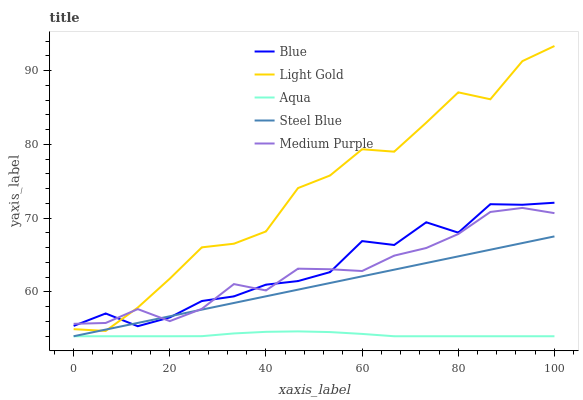Does Aqua have the minimum area under the curve?
Answer yes or no. Yes. Does Light Gold have the maximum area under the curve?
Answer yes or no. Yes. Does Medium Purple have the minimum area under the curve?
Answer yes or no. No. Does Medium Purple have the maximum area under the curve?
Answer yes or no. No. Is Steel Blue the smoothest?
Answer yes or no. Yes. Is Light Gold the roughest?
Answer yes or no. Yes. Is Aqua the smoothest?
Answer yes or no. No. Is Aqua the roughest?
Answer yes or no. No. Does Aqua have the lowest value?
Answer yes or no. Yes. Does Medium Purple have the lowest value?
Answer yes or no. No. Does Light Gold have the highest value?
Answer yes or no. Yes. Does Medium Purple have the highest value?
Answer yes or no. No. Is Aqua less than Light Gold?
Answer yes or no. Yes. Is Blue greater than Aqua?
Answer yes or no. Yes. Does Light Gold intersect Medium Purple?
Answer yes or no. Yes. Is Light Gold less than Medium Purple?
Answer yes or no. No. Is Light Gold greater than Medium Purple?
Answer yes or no. No. Does Aqua intersect Light Gold?
Answer yes or no. No. 